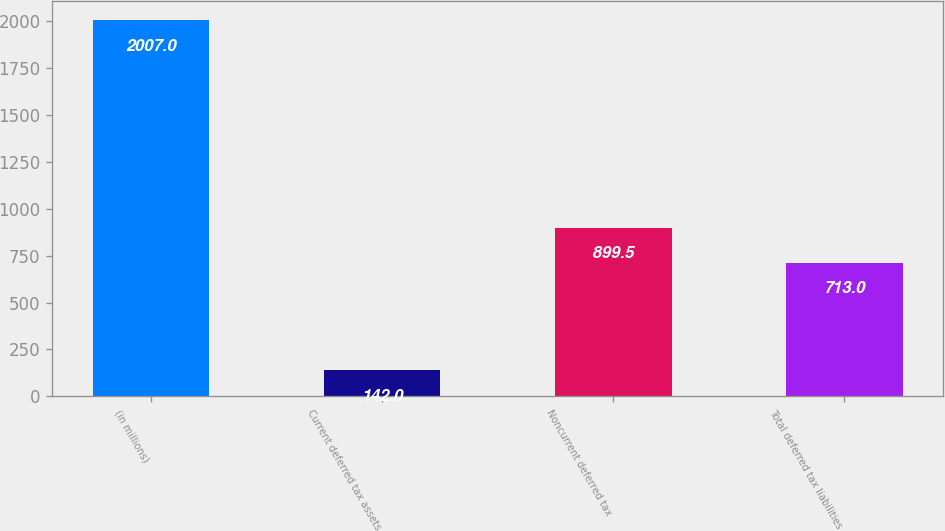Convert chart. <chart><loc_0><loc_0><loc_500><loc_500><bar_chart><fcel>(in millions)<fcel>Current deferred tax assets<fcel>Noncurrent deferred tax<fcel>Total deferred tax liabilities<nl><fcel>2007<fcel>142<fcel>899.5<fcel>713<nl></chart> 